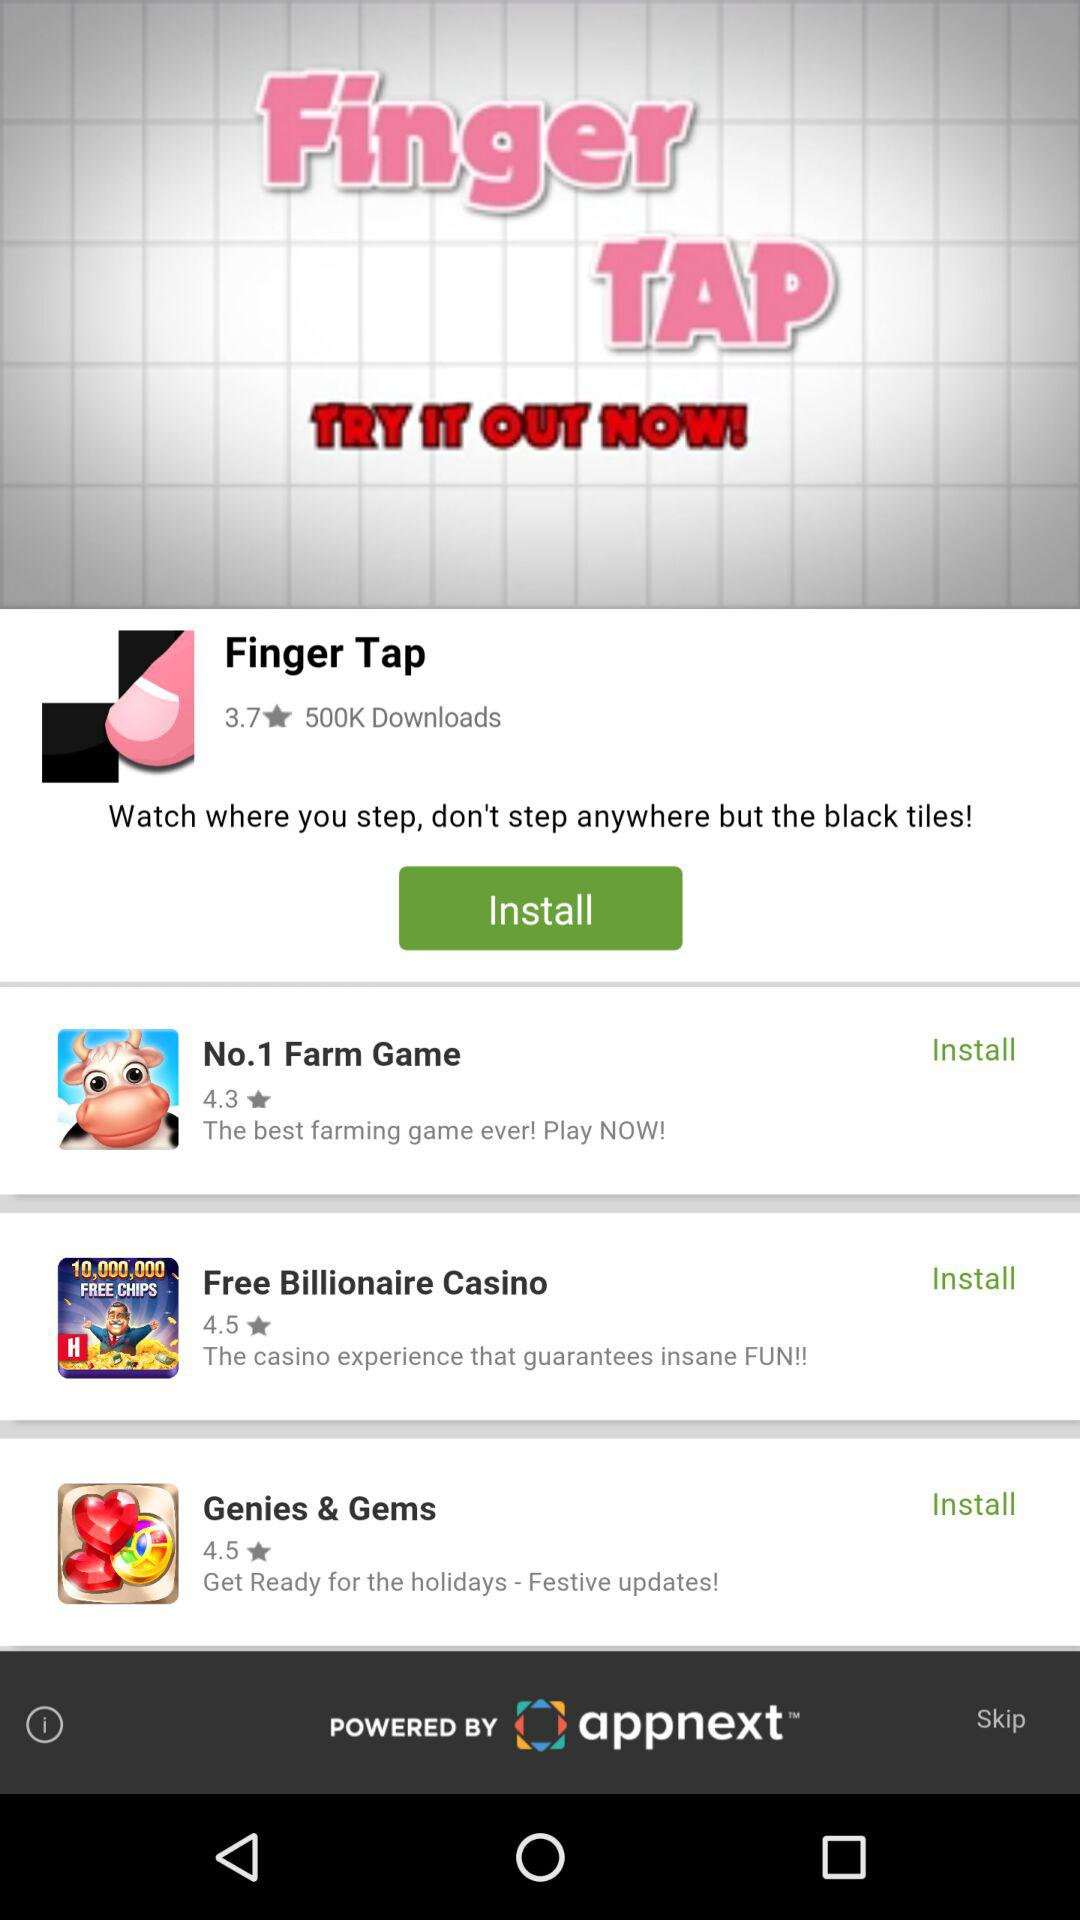What is the status of the No. 1 farm game?
When the provided information is insufficient, respond with <no answer>. <no answer> 